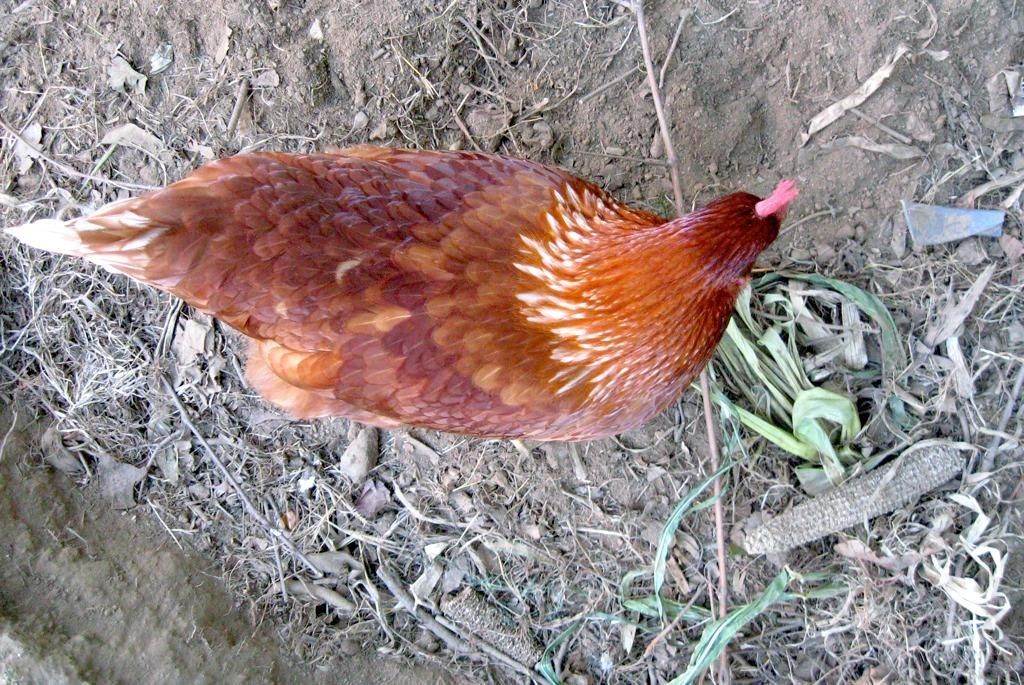What is the main subject in the center of the image? There is a standing object in the center of the image. What can be seen beneath the standing object? The ground is visible in the image. What type of vegetation is present on the ground? There is dry grass on the ground. What type of liquid can be seen flowing from the board in the image? There is no board or liquid present in the image. 